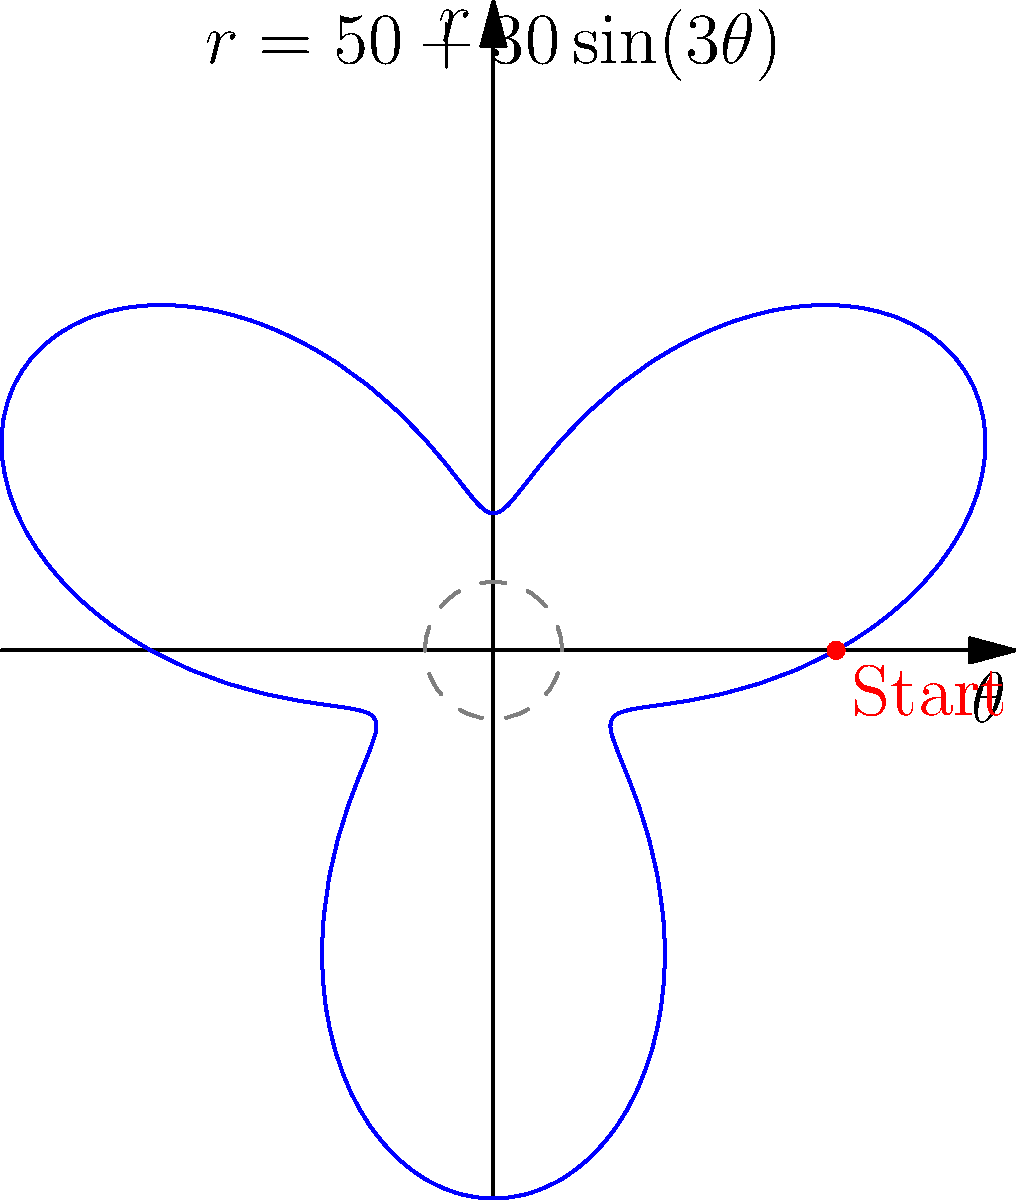As a documentary filmmaker capturing the stories of Wall Street veterans, you're exploring innovative ways to visualize stock price movements. You've come across a method using polar coordinates to plot a stock's price trajectory. The equation $r = 50 + 30\sin(3\theta)$ represents the stock price ($r$) as a function of time ($\theta$) over a complete market cycle. What is the maximum stock price reached during this cycle? To find the maximum stock price, we need to follow these steps:

1) The stock price is represented by $r$ in the equation $r = 50 + 30\sin(3\theta)$.

2) The base price is 50, and it oscillates with an amplitude of 30.

3) The $\sin$ function has a range of [-1, 1].

4) The maximum value of $\sin(3\theta)$ is 1.

5) Therefore, the maximum value of $r$ occurs when $\sin(3\theta) = 1$.

6) Substituting this into the equation:

   $r_{max} = 50 + 30(1) = 50 + 30 = 80$

Thus, the maximum stock price reached during this cycle is 80.
Answer: 80 